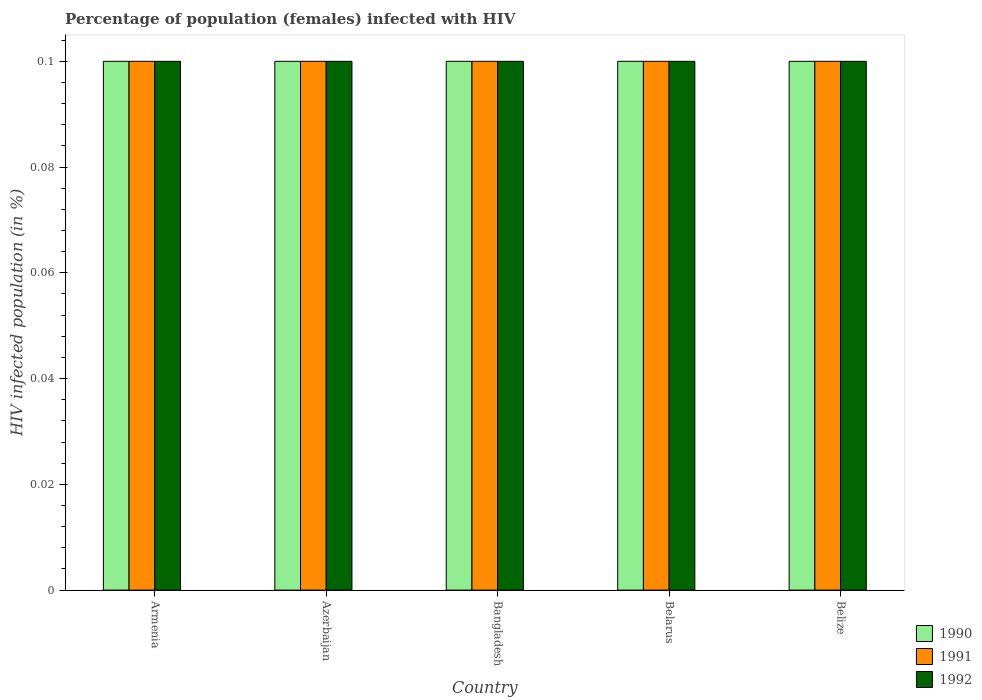How many different coloured bars are there?
Offer a terse response. 3. How many groups of bars are there?
Offer a very short reply. 5. How many bars are there on the 1st tick from the right?
Provide a succinct answer. 3. What is the label of the 2nd group of bars from the left?
Your response must be concise. Azerbaijan. In which country was the percentage of HIV infected female population in 1991 maximum?
Give a very brief answer. Armenia. In which country was the percentage of HIV infected female population in 1990 minimum?
Provide a succinct answer. Armenia. What is the total percentage of HIV infected female population in 1992 in the graph?
Your answer should be very brief. 0.5. What is the ratio of the percentage of HIV infected female population in 1990 in Armenia to that in Belize?
Your response must be concise. 1. What is the difference between the highest and the lowest percentage of HIV infected female population in 1990?
Ensure brevity in your answer.  0. Is the sum of the percentage of HIV infected female population in 1991 in Azerbaijan and Bangladesh greater than the maximum percentage of HIV infected female population in 1990 across all countries?
Your answer should be compact. Yes. Are all the bars in the graph horizontal?
Your answer should be very brief. No. Are the values on the major ticks of Y-axis written in scientific E-notation?
Keep it short and to the point. No. Does the graph contain any zero values?
Provide a short and direct response. No. Does the graph contain grids?
Keep it short and to the point. No. Where does the legend appear in the graph?
Provide a succinct answer. Bottom right. How many legend labels are there?
Give a very brief answer. 3. How are the legend labels stacked?
Give a very brief answer. Vertical. What is the title of the graph?
Offer a very short reply. Percentage of population (females) infected with HIV. What is the label or title of the Y-axis?
Keep it short and to the point. HIV infected population (in %). What is the HIV infected population (in %) in 1990 in Armenia?
Make the answer very short. 0.1. What is the HIV infected population (in %) of 1992 in Armenia?
Keep it short and to the point. 0.1. What is the HIV infected population (in %) of 1990 in Azerbaijan?
Offer a terse response. 0.1. What is the HIV infected population (in %) in 1990 in Belarus?
Your answer should be compact. 0.1. What is the HIV infected population (in %) of 1991 in Belarus?
Offer a terse response. 0.1. What is the HIV infected population (in %) in 1991 in Belize?
Make the answer very short. 0.1. What is the HIV infected population (in %) in 1992 in Belize?
Provide a succinct answer. 0.1. Across all countries, what is the maximum HIV infected population (in %) in 1991?
Ensure brevity in your answer.  0.1. Across all countries, what is the minimum HIV infected population (in %) of 1992?
Provide a succinct answer. 0.1. What is the total HIV infected population (in %) in 1990 in the graph?
Ensure brevity in your answer.  0.5. What is the total HIV infected population (in %) of 1991 in the graph?
Your answer should be very brief. 0.5. What is the total HIV infected population (in %) in 1992 in the graph?
Offer a very short reply. 0.5. What is the difference between the HIV infected population (in %) of 1992 in Armenia and that in Azerbaijan?
Your answer should be compact. 0. What is the difference between the HIV infected population (in %) in 1991 in Armenia and that in Bangladesh?
Provide a succinct answer. 0. What is the difference between the HIV infected population (in %) in 1992 in Armenia and that in Bangladesh?
Make the answer very short. 0. What is the difference between the HIV infected population (in %) of 1991 in Armenia and that in Belarus?
Your response must be concise. 0. What is the difference between the HIV infected population (in %) in 1992 in Armenia and that in Belarus?
Ensure brevity in your answer.  0. What is the difference between the HIV infected population (in %) of 1992 in Armenia and that in Belize?
Make the answer very short. 0. What is the difference between the HIV infected population (in %) in 1990 in Azerbaijan and that in Bangladesh?
Your response must be concise. 0. What is the difference between the HIV infected population (in %) in 1992 in Azerbaijan and that in Bangladesh?
Make the answer very short. 0. What is the difference between the HIV infected population (in %) in 1991 in Azerbaijan and that in Belarus?
Provide a succinct answer. 0. What is the difference between the HIV infected population (in %) in 1992 in Azerbaijan and that in Belarus?
Ensure brevity in your answer.  0. What is the difference between the HIV infected population (in %) in 1991 in Azerbaijan and that in Belize?
Offer a very short reply. 0. What is the difference between the HIV infected population (in %) of 1992 in Bangladesh and that in Belize?
Offer a terse response. 0. What is the difference between the HIV infected population (in %) in 1990 in Belarus and that in Belize?
Your answer should be compact. 0. What is the difference between the HIV infected population (in %) in 1991 in Belarus and that in Belize?
Ensure brevity in your answer.  0. What is the difference between the HIV infected population (in %) in 1990 in Armenia and the HIV infected population (in %) in 1991 in Azerbaijan?
Make the answer very short. 0. What is the difference between the HIV infected population (in %) of 1991 in Armenia and the HIV infected population (in %) of 1992 in Azerbaijan?
Offer a terse response. 0. What is the difference between the HIV infected population (in %) in 1990 in Armenia and the HIV infected population (in %) in 1992 in Bangladesh?
Provide a short and direct response. 0. What is the difference between the HIV infected population (in %) in 1991 in Armenia and the HIV infected population (in %) in 1992 in Bangladesh?
Provide a short and direct response. 0. What is the difference between the HIV infected population (in %) in 1991 in Armenia and the HIV infected population (in %) in 1992 in Belarus?
Make the answer very short. 0. What is the difference between the HIV infected population (in %) of 1990 in Armenia and the HIV infected population (in %) of 1992 in Belize?
Provide a short and direct response. 0. What is the difference between the HIV infected population (in %) of 1990 in Azerbaijan and the HIV infected population (in %) of 1991 in Bangladesh?
Provide a short and direct response. 0. What is the difference between the HIV infected population (in %) of 1991 in Azerbaijan and the HIV infected population (in %) of 1992 in Bangladesh?
Your response must be concise. 0. What is the difference between the HIV infected population (in %) in 1990 in Azerbaijan and the HIV infected population (in %) in 1991 in Belarus?
Provide a succinct answer. 0. What is the difference between the HIV infected population (in %) of 1990 in Azerbaijan and the HIV infected population (in %) of 1992 in Belarus?
Your answer should be very brief. 0. What is the difference between the HIV infected population (in %) of 1990 in Bangladesh and the HIV infected population (in %) of 1992 in Belarus?
Make the answer very short. 0. What is the difference between the HIV infected population (in %) of 1990 in Bangladesh and the HIV infected population (in %) of 1991 in Belize?
Ensure brevity in your answer.  0. What is the difference between the HIV infected population (in %) in 1990 in Belarus and the HIV infected population (in %) in 1991 in Belize?
Provide a succinct answer. 0. What is the difference between the HIV infected population (in %) of 1991 in Belarus and the HIV infected population (in %) of 1992 in Belize?
Your response must be concise. 0. What is the average HIV infected population (in %) in 1991 per country?
Offer a terse response. 0.1. What is the average HIV infected population (in %) of 1992 per country?
Your answer should be very brief. 0.1. What is the difference between the HIV infected population (in %) of 1991 and HIV infected population (in %) of 1992 in Armenia?
Your answer should be compact. 0. What is the difference between the HIV infected population (in %) of 1990 and HIV infected population (in %) of 1991 in Azerbaijan?
Make the answer very short. 0. What is the difference between the HIV infected population (in %) of 1990 and HIV infected population (in %) of 1992 in Bangladesh?
Ensure brevity in your answer.  0. What is the difference between the HIV infected population (in %) in 1990 and HIV infected population (in %) in 1991 in Belarus?
Your answer should be very brief. 0. What is the difference between the HIV infected population (in %) of 1991 and HIV infected population (in %) of 1992 in Belarus?
Keep it short and to the point. 0. What is the difference between the HIV infected population (in %) in 1990 and HIV infected population (in %) in 1991 in Belize?
Offer a terse response. 0. What is the difference between the HIV infected population (in %) of 1991 and HIV infected population (in %) of 1992 in Belize?
Give a very brief answer. 0. What is the ratio of the HIV infected population (in %) in 1990 in Armenia to that in Azerbaijan?
Provide a succinct answer. 1. What is the ratio of the HIV infected population (in %) of 1991 in Armenia to that in Azerbaijan?
Provide a short and direct response. 1. What is the ratio of the HIV infected population (in %) in 1992 in Armenia to that in Azerbaijan?
Your answer should be very brief. 1. What is the ratio of the HIV infected population (in %) of 1990 in Armenia to that in Bangladesh?
Your response must be concise. 1. What is the ratio of the HIV infected population (in %) in 1992 in Armenia to that in Bangladesh?
Your answer should be compact. 1. What is the ratio of the HIV infected population (in %) in 1990 in Armenia to that in Belarus?
Keep it short and to the point. 1. What is the ratio of the HIV infected population (in %) of 1990 in Armenia to that in Belize?
Provide a short and direct response. 1. What is the ratio of the HIV infected population (in %) of 1990 in Azerbaijan to that in Bangladesh?
Keep it short and to the point. 1. What is the ratio of the HIV infected population (in %) in 1992 in Azerbaijan to that in Bangladesh?
Ensure brevity in your answer.  1. What is the ratio of the HIV infected population (in %) of 1990 in Azerbaijan to that in Belarus?
Offer a terse response. 1. What is the ratio of the HIV infected population (in %) of 1991 in Azerbaijan to that in Belarus?
Your response must be concise. 1. What is the ratio of the HIV infected population (in %) of 1990 in Azerbaijan to that in Belize?
Offer a terse response. 1. What is the ratio of the HIV infected population (in %) in 1991 in Azerbaijan to that in Belize?
Your answer should be compact. 1. What is the ratio of the HIV infected population (in %) of 1992 in Azerbaijan to that in Belize?
Ensure brevity in your answer.  1. What is the ratio of the HIV infected population (in %) in 1990 in Bangladesh to that in Belarus?
Your answer should be very brief. 1. What is the ratio of the HIV infected population (in %) of 1992 in Bangladesh to that in Belarus?
Offer a very short reply. 1. What is the ratio of the HIV infected population (in %) in 1990 in Bangladesh to that in Belize?
Make the answer very short. 1. What is the ratio of the HIV infected population (in %) in 1991 in Bangladesh to that in Belize?
Make the answer very short. 1. What is the difference between the highest and the lowest HIV infected population (in %) of 1991?
Your answer should be compact. 0. What is the difference between the highest and the lowest HIV infected population (in %) in 1992?
Offer a very short reply. 0. 